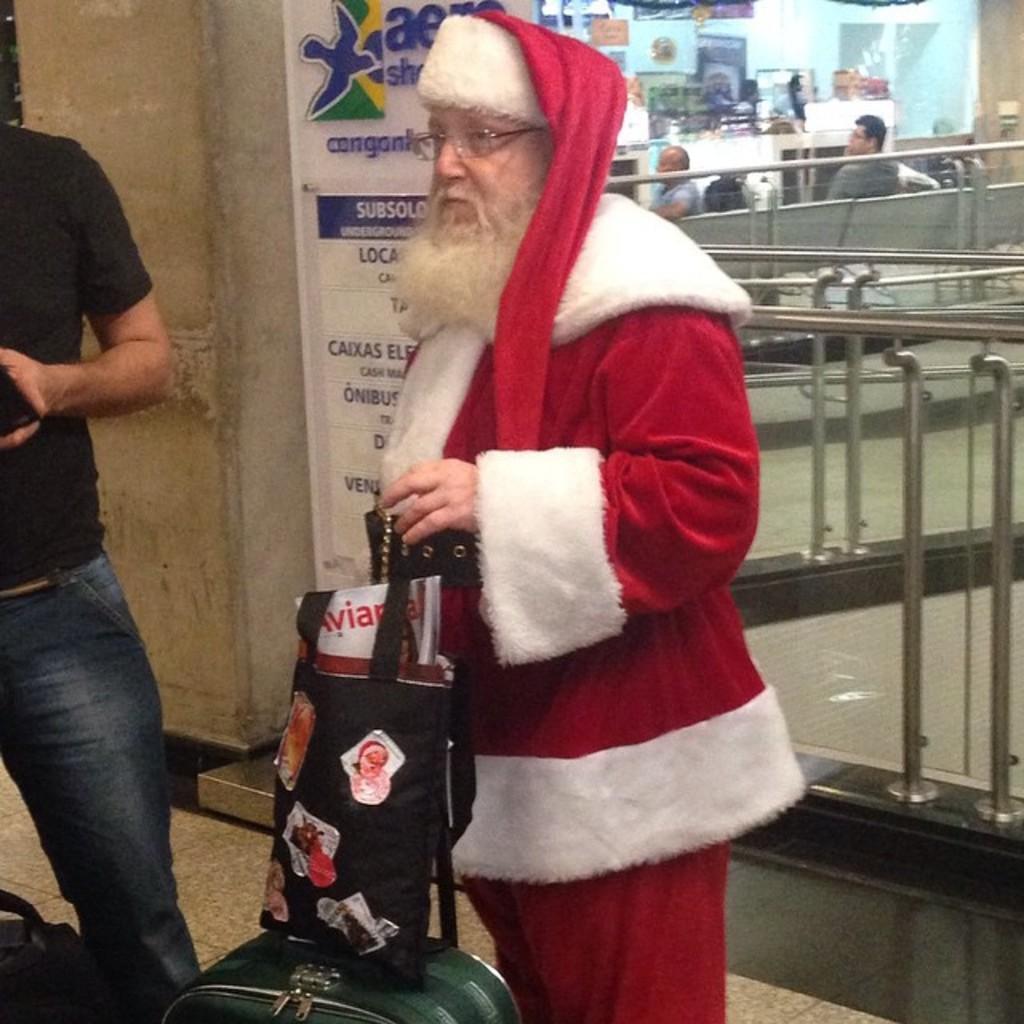How would you summarize this image in a sentence or two? In the middle an old man is standing in the Christmas dress. On the left side there is another person. This person wore black color t-shirt, on the right side 2 persons are sitting on the bench. 